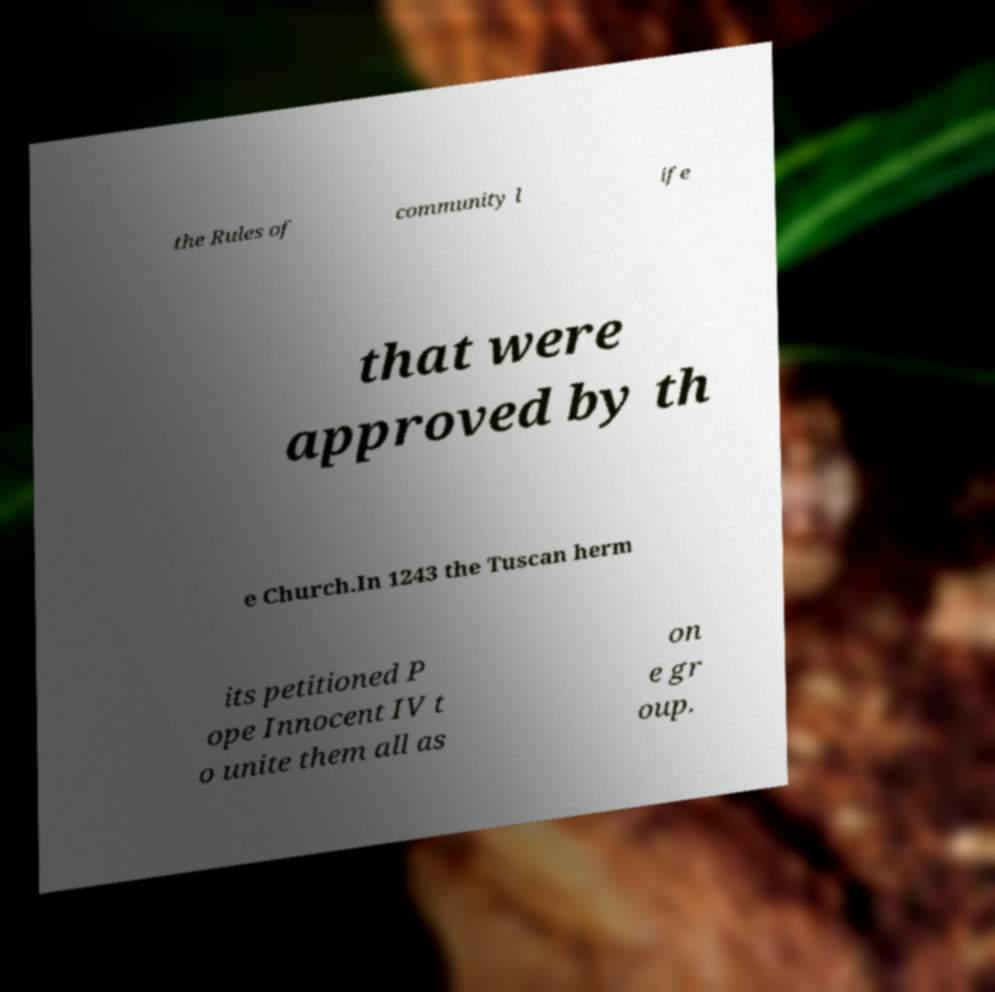There's text embedded in this image that I need extracted. Can you transcribe it verbatim? the Rules of community l ife that were approved by th e Church.In 1243 the Tuscan herm its petitioned P ope Innocent IV t o unite them all as on e gr oup. 